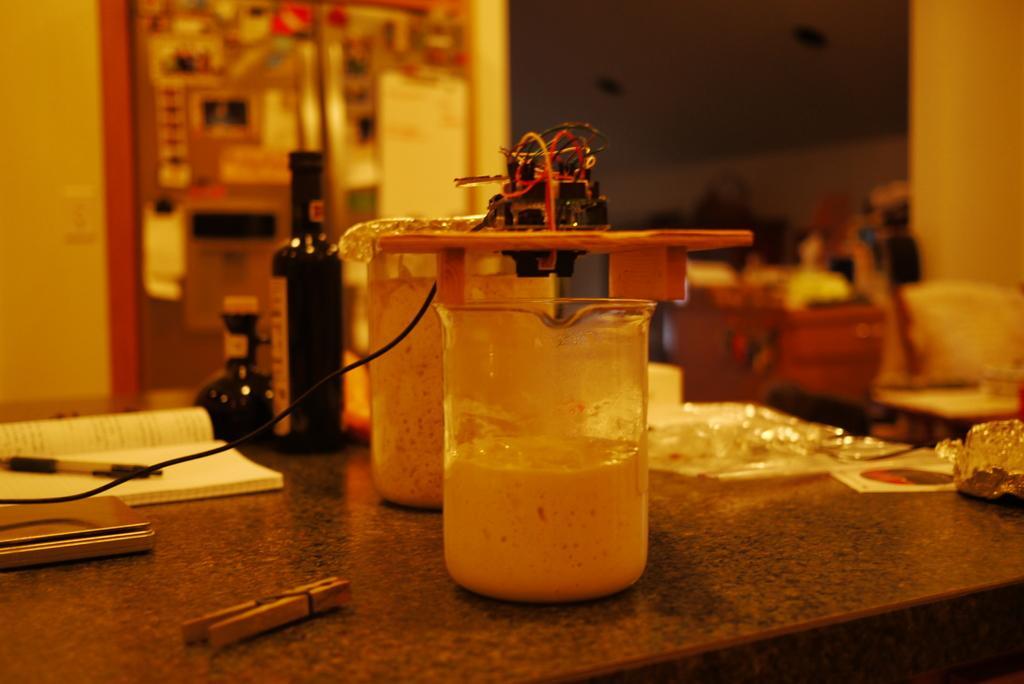How would you summarize this image in a sentence or two? In this image there is a book, pen and an object in the left corner. There is a chair and cupboard with objects on it in the right corner. There is a table with bottle and some objects on it in the foreground. And there is wall and door in the background. 